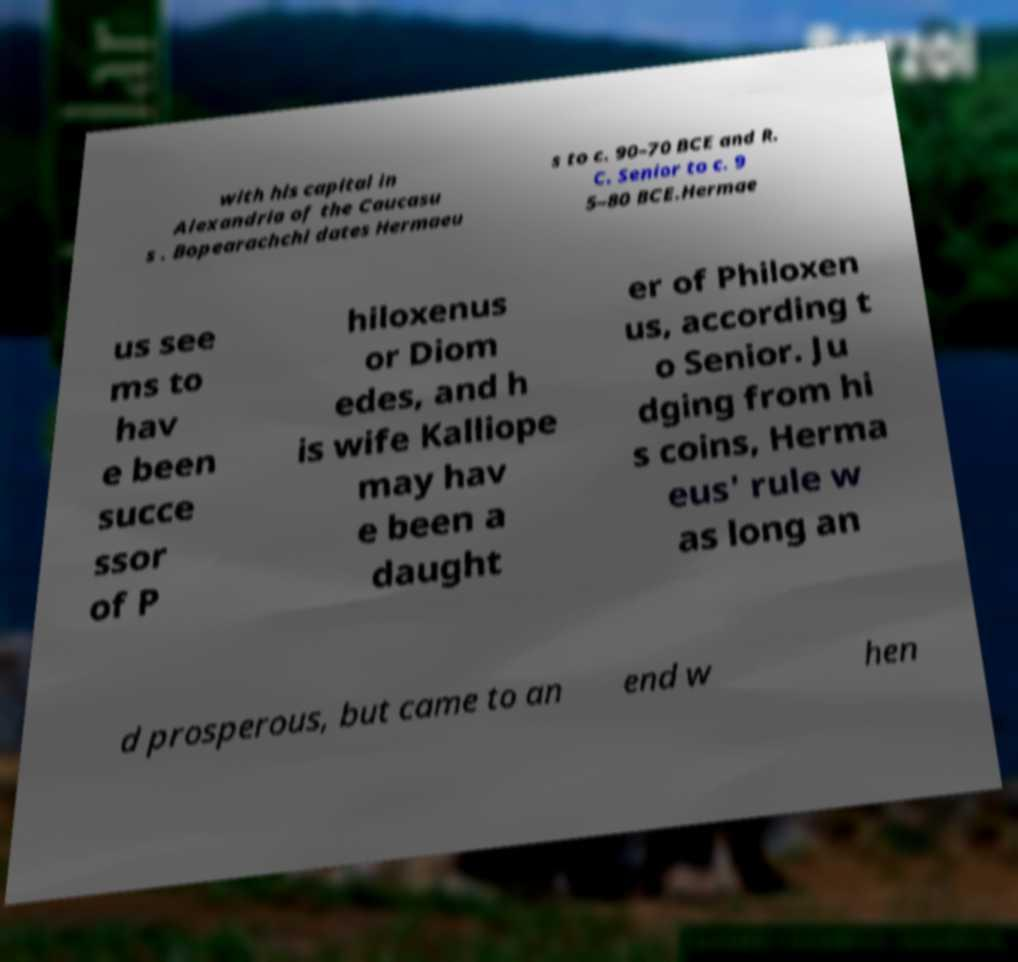Can you read and provide the text displayed in the image?This photo seems to have some interesting text. Can you extract and type it out for me? with his capital in Alexandria of the Caucasu s . Bopearachchi dates Hermaeu s to c. 90–70 BCE and R. C. Senior to c. 9 5–80 BCE.Hermae us see ms to hav e been succe ssor of P hiloxenus or Diom edes, and h is wife Kalliope may hav e been a daught er of Philoxen us, according t o Senior. Ju dging from hi s coins, Herma eus' rule w as long an d prosperous, but came to an end w hen 